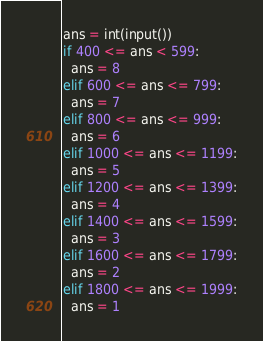Convert code to text. <code><loc_0><loc_0><loc_500><loc_500><_Python_>ans = int(input())
if 400 <= ans < 599:
  ans = 8
elif 600 <= ans <= 799:
  ans = 7
elif 800 <= ans <= 999:
  ans = 6
elif 1000 <= ans <= 1199:
  ans = 5
elif 1200 <= ans <= 1399:
  ans = 4
elif 1400 <= ans <= 1599:
  ans = 3
elif 1600 <= ans <= 1799:
  ans = 2
elif 1800 <= ans <= 1999:
  ans = 1
</code> 